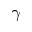<formula> <loc_0><loc_0><loc_500><loc_500>\gamma</formula> 